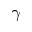<formula> <loc_0><loc_0><loc_500><loc_500>\gamma</formula> 